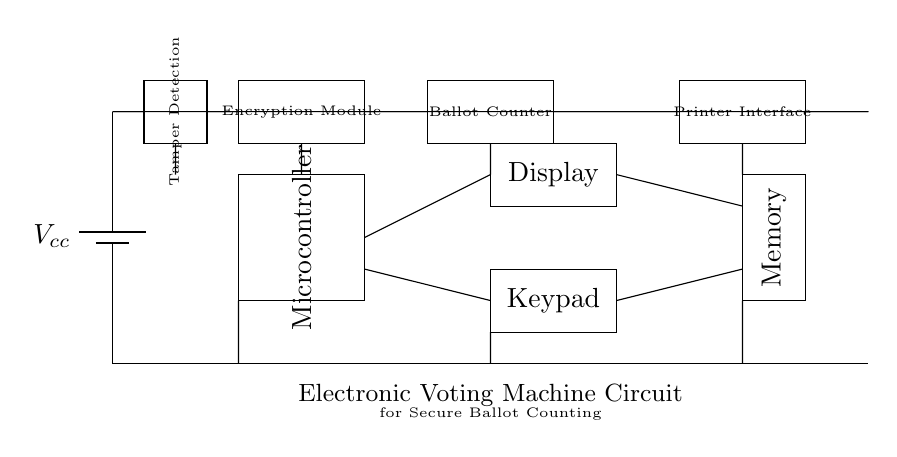What is the main processing unit of the circuit? The microcontroller, which is represented by a rectangle labeled "Microcontroller" in the circuit diagram, is the main processing unit that manages operations.
Answer: Microcontroller How many main components are directly involved in ballot counting? The ballot counter, microcontroller, and display are directly involved in processing and showing the ballot count, totaling three main components.
Answer: Three What is the function of the encryption module? The encryption module ensures that the data being processed by the circuit, particularly sensitive information like votes, is securely encoded to protect against unauthorized access.
Answer: Security Which component detects tampering? The tamper detection component, represented by a rectangle labeled "Tamper Detection," monitors for unauthorized modifications to the hardware or software.
Answer: Tamper Detection What type of interface is used for printing results? The printer interface is used to connect to a printer for printing out the election results, providing a physical record of the votes counted.
Answer: Printer Interface How is power supplied to the circuit? The circuit is powered by a battery, indicated as "Vcc" which supplies the necessary voltage for the operation of the components in the circuit.
Answer: Battery What is the purpose of the memory component? The memory component stores the ballot data temporarily during processing, allowing the microcontroller to access and manage the information effectively.
Answer: Storage 